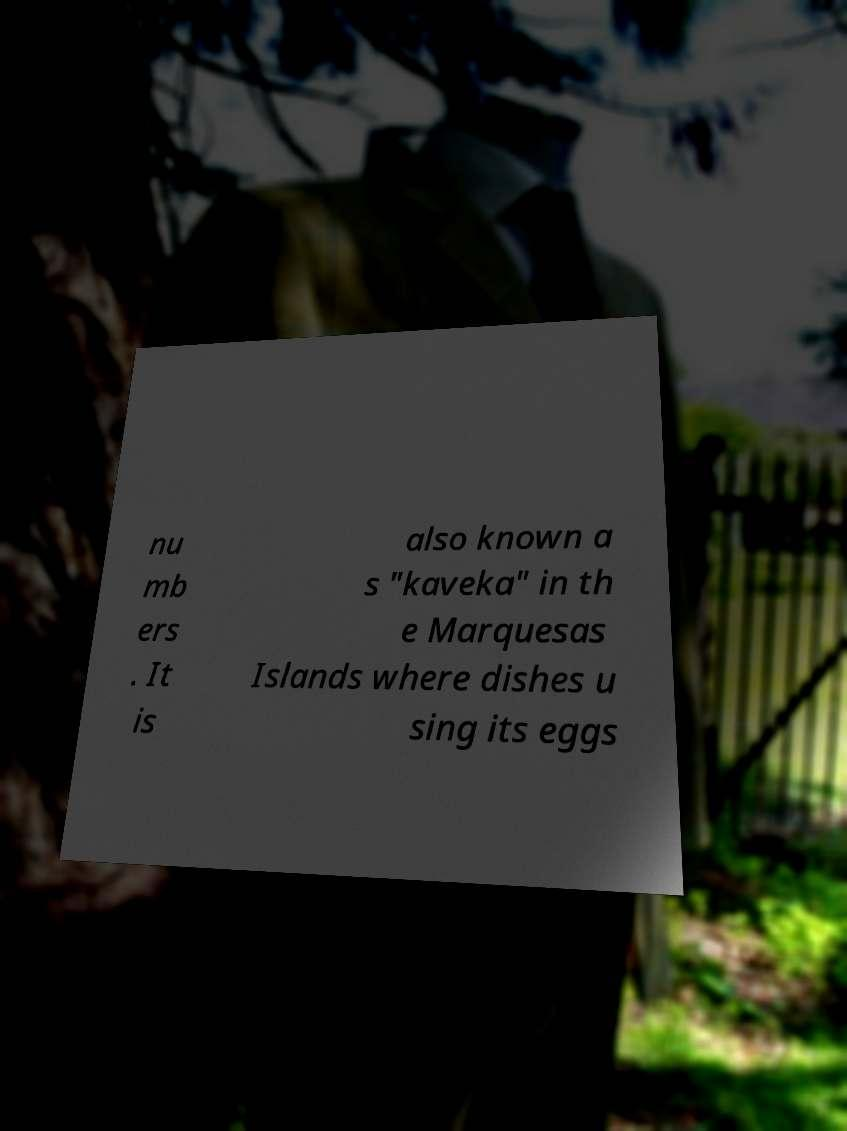Can you accurately transcribe the text from the provided image for me? nu mb ers . It is also known a s "kaveka" in th e Marquesas Islands where dishes u sing its eggs 